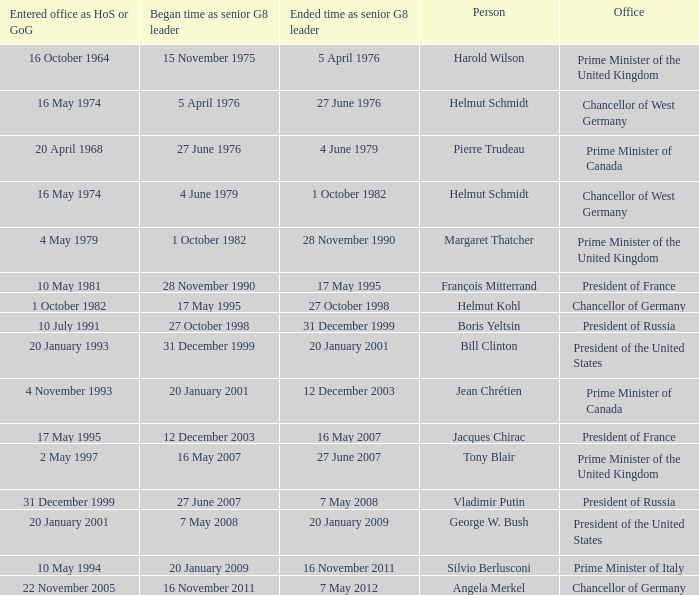When did jacques chirac cease being a g8 leader? 16 May 2007. Would you be able to parse every entry in this table? {'header': ['Entered office as HoS or GoG', 'Began time as senior G8 leader', 'Ended time as senior G8 leader', 'Person', 'Office'], 'rows': [['16 October 1964', '15 November 1975', '5 April 1976', 'Harold Wilson', 'Prime Minister of the United Kingdom'], ['16 May 1974', '5 April 1976', '27 June 1976', 'Helmut Schmidt', 'Chancellor of West Germany'], ['20 April 1968', '27 June 1976', '4 June 1979', 'Pierre Trudeau', 'Prime Minister of Canada'], ['16 May 1974', '4 June 1979', '1 October 1982', 'Helmut Schmidt', 'Chancellor of West Germany'], ['4 May 1979', '1 October 1982', '28 November 1990', 'Margaret Thatcher', 'Prime Minister of the United Kingdom'], ['10 May 1981', '28 November 1990', '17 May 1995', 'François Mitterrand', 'President of France'], ['1 October 1982', '17 May 1995', '27 October 1998', 'Helmut Kohl', 'Chancellor of Germany'], ['10 July 1991', '27 October 1998', '31 December 1999', 'Boris Yeltsin', 'President of Russia'], ['20 January 1993', '31 December 1999', '20 January 2001', 'Bill Clinton', 'President of the United States'], ['4 November 1993', '20 January 2001', '12 December 2003', 'Jean Chrétien', 'Prime Minister of Canada'], ['17 May 1995', '12 December 2003', '16 May 2007', 'Jacques Chirac', 'President of France'], ['2 May 1997', '16 May 2007', '27 June 2007', 'Tony Blair', 'Prime Minister of the United Kingdom'], ['31 December 1999', '27 June 2007', '7 May 2008', 'Vladimir Putin', 'President of Russia'], ['20 January 2001', '7 May 2008', '20 January 2009', 'George W. Bush', 'President of the United States'], ['10 May 1994', '20 January 2009', '16 November 2011', 'Silvio Berlusconi', 'Prime Minister of Italy'], ['22 November 2005', '16 November 2011', '7 May 2012', 'Angela Merkel', 'Chancellor of Germany']]} 